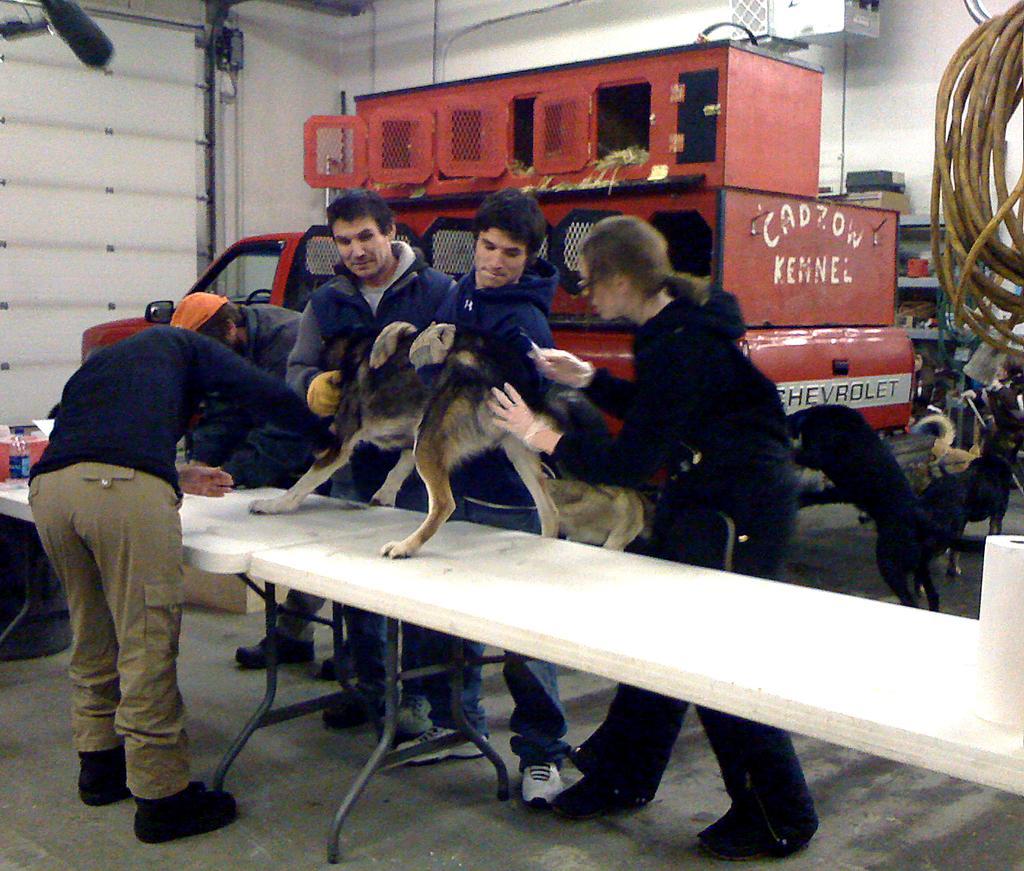How would you summarize this image in a sentence or two? In the image we can see there are people who are holding a dog and the dog is standing on the table and on the other side there are dogs which are standing on the floor. 